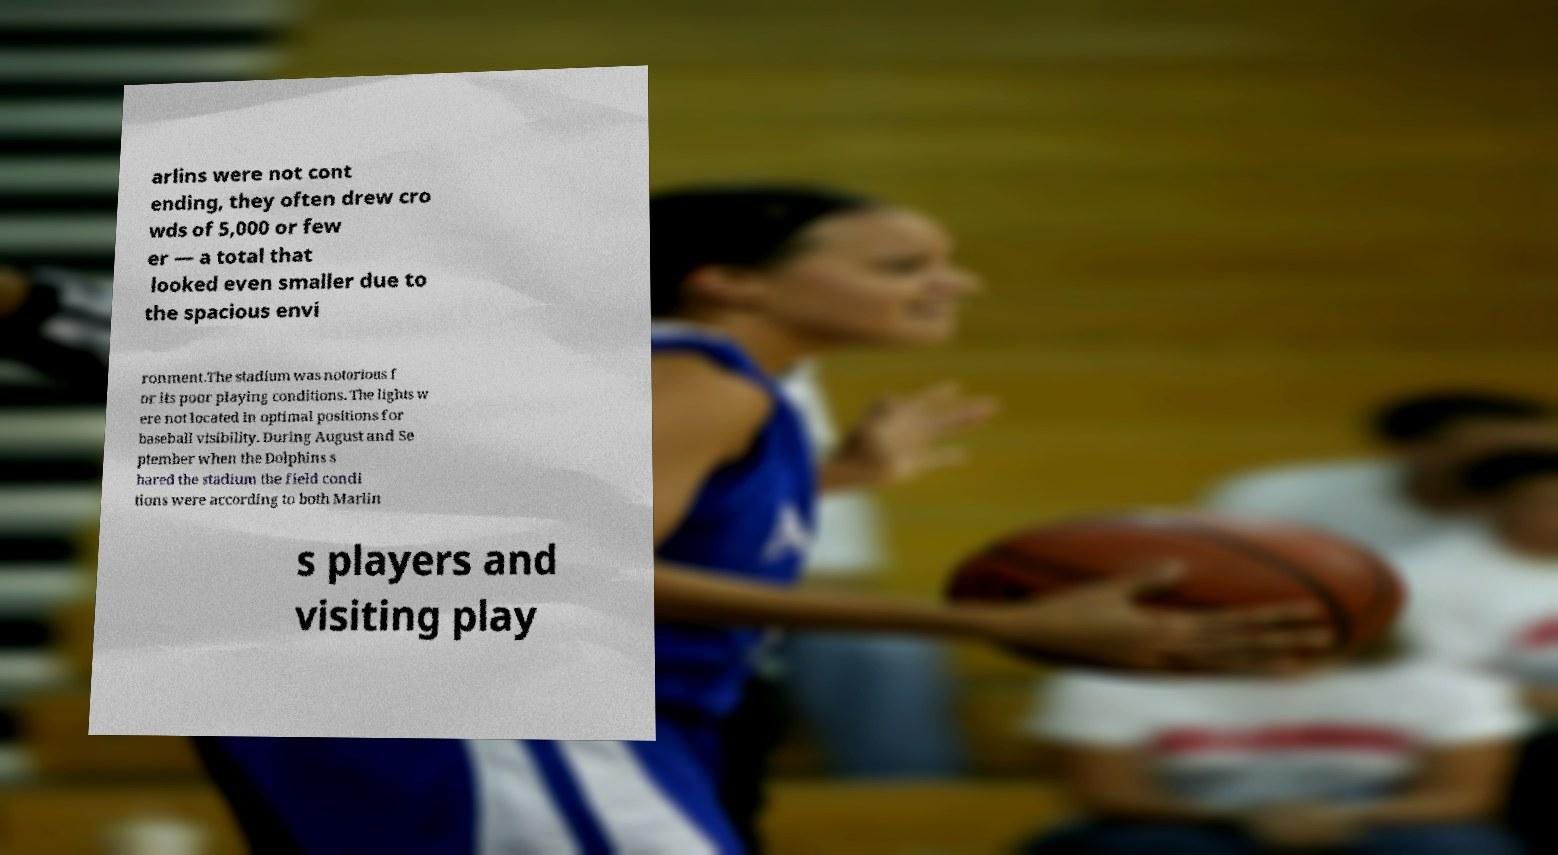Can you read and provide the text displayed in the image?This photo seems to have some interesting text. Can you extract and type it out for me? arlins were not cont ending, they often drew cro wds of 5,000 or few er — a total that looked even smaller due to the spacious envi ronment.The stadium was notorious f or its poor playing conditions. The lights w ere not located in optimal positions for baseball visibility. During August and Se ptember when the Dolphins s hared the stadium the field condi tions were according to both Marlin s players and visiting play 